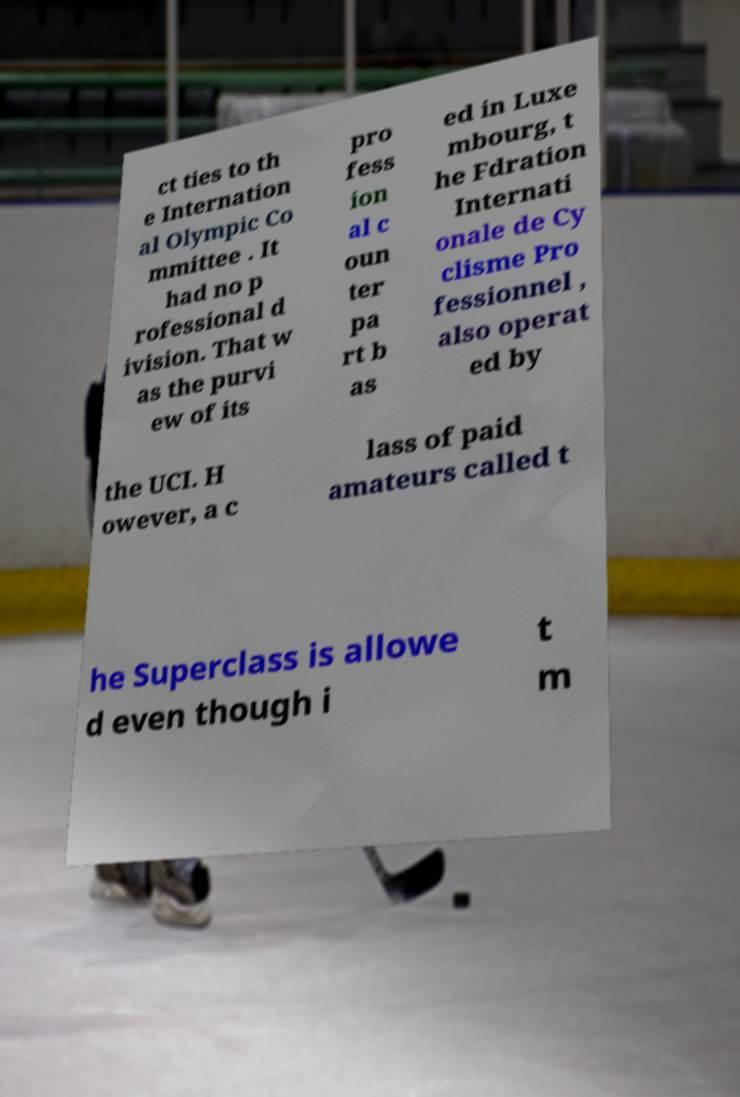There's text embedded in this image that I need extracted. Can you transcribe it verbatim? ct ties to th e Internation al Olympic Co mmittee . It had no p rofessional d ivision. That w as the purvi ew of its pro fess ion al c oun ter pa rt b as ed in Luxe mbourg, t he Fdration Internati onale de Cy clisme Pro fessionnel , also operat ed by the UCI. H owever, a c lass of paid amateurs called t he Superclass is allowe d even though i t m 